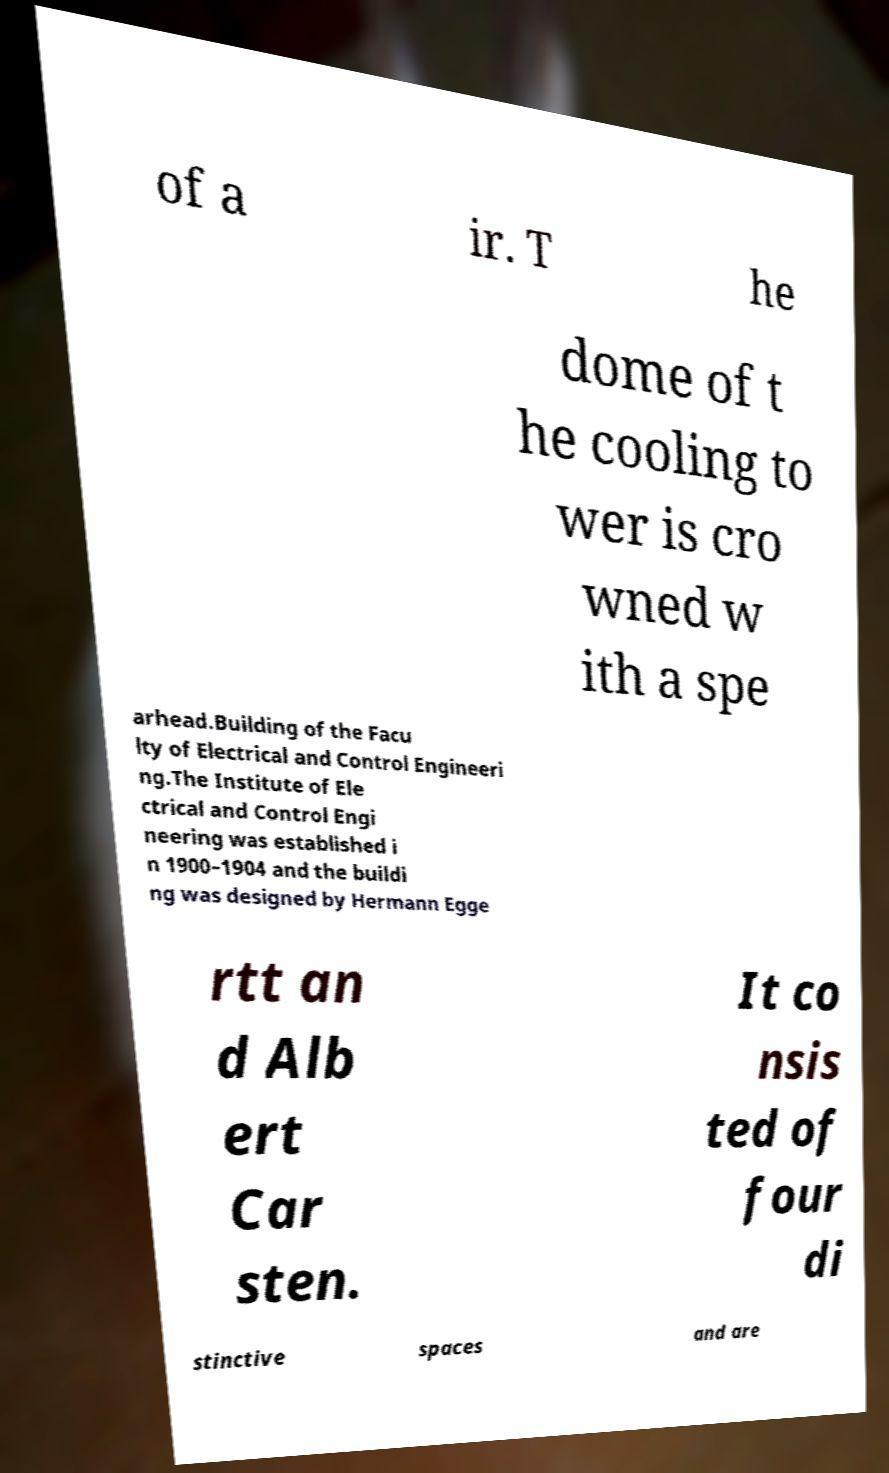For documentation purposes, I need the text within this image transcribed. Could you provide that? of a ir. T he dome of t he cooling to wer is cro wned w ith a spe arhead.Building of the Facu lty of Electrical and Control Engineeri ng.The Institute of Ele ctrical and Control Engi neering was established i n 1900–1904 and the buildi ng was designed by Hermann Egge rtt an d Alb ert Car sten. It co nsis ted of four di stinctive spaces and are 